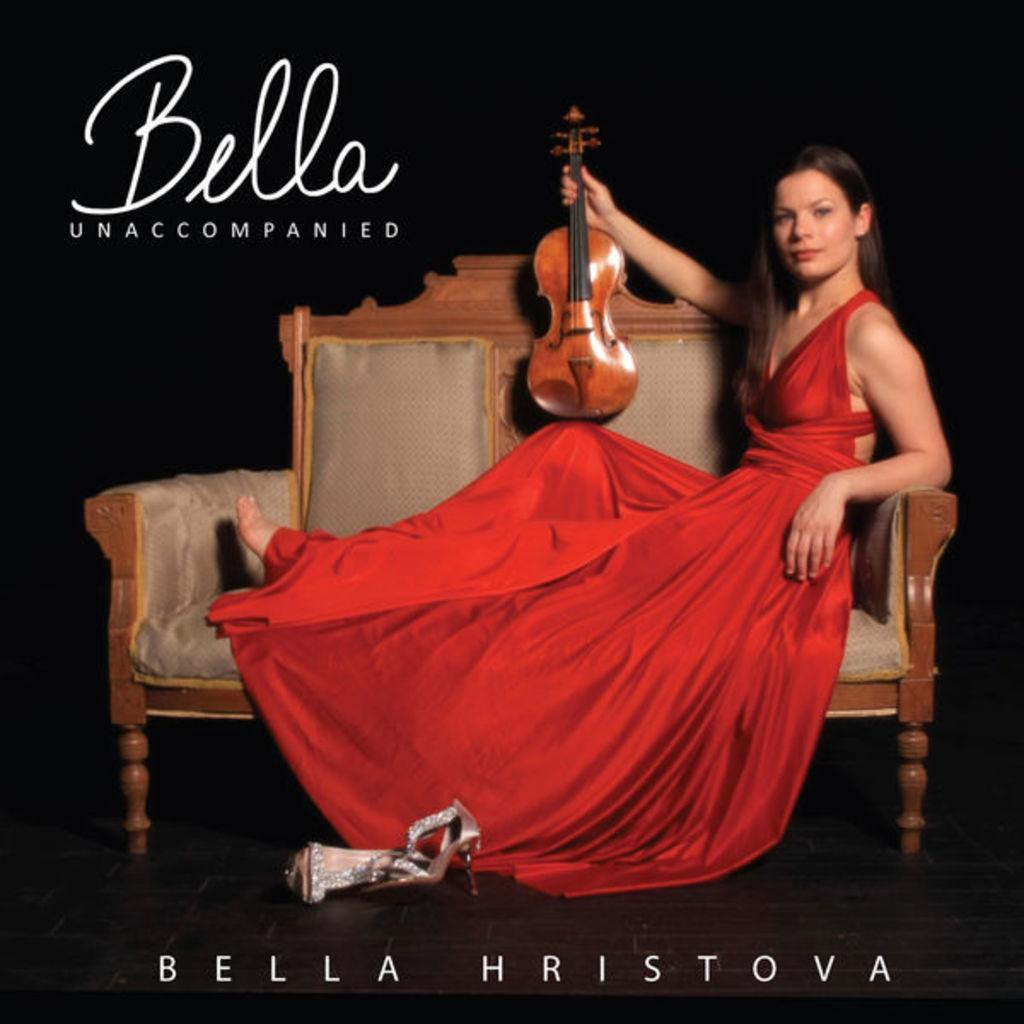Who is present in the image? There is a woman in the image. What is the woman doing in the image? The woman is sitting on a sofa and holding a violin. What can be seen at the top and bottom of the image? There is text at the top and bottom of the image. What type of nail is the woman using to play the violin in the image? There is no nail visible in the image, and the woman is not using any nail to play the violin. 